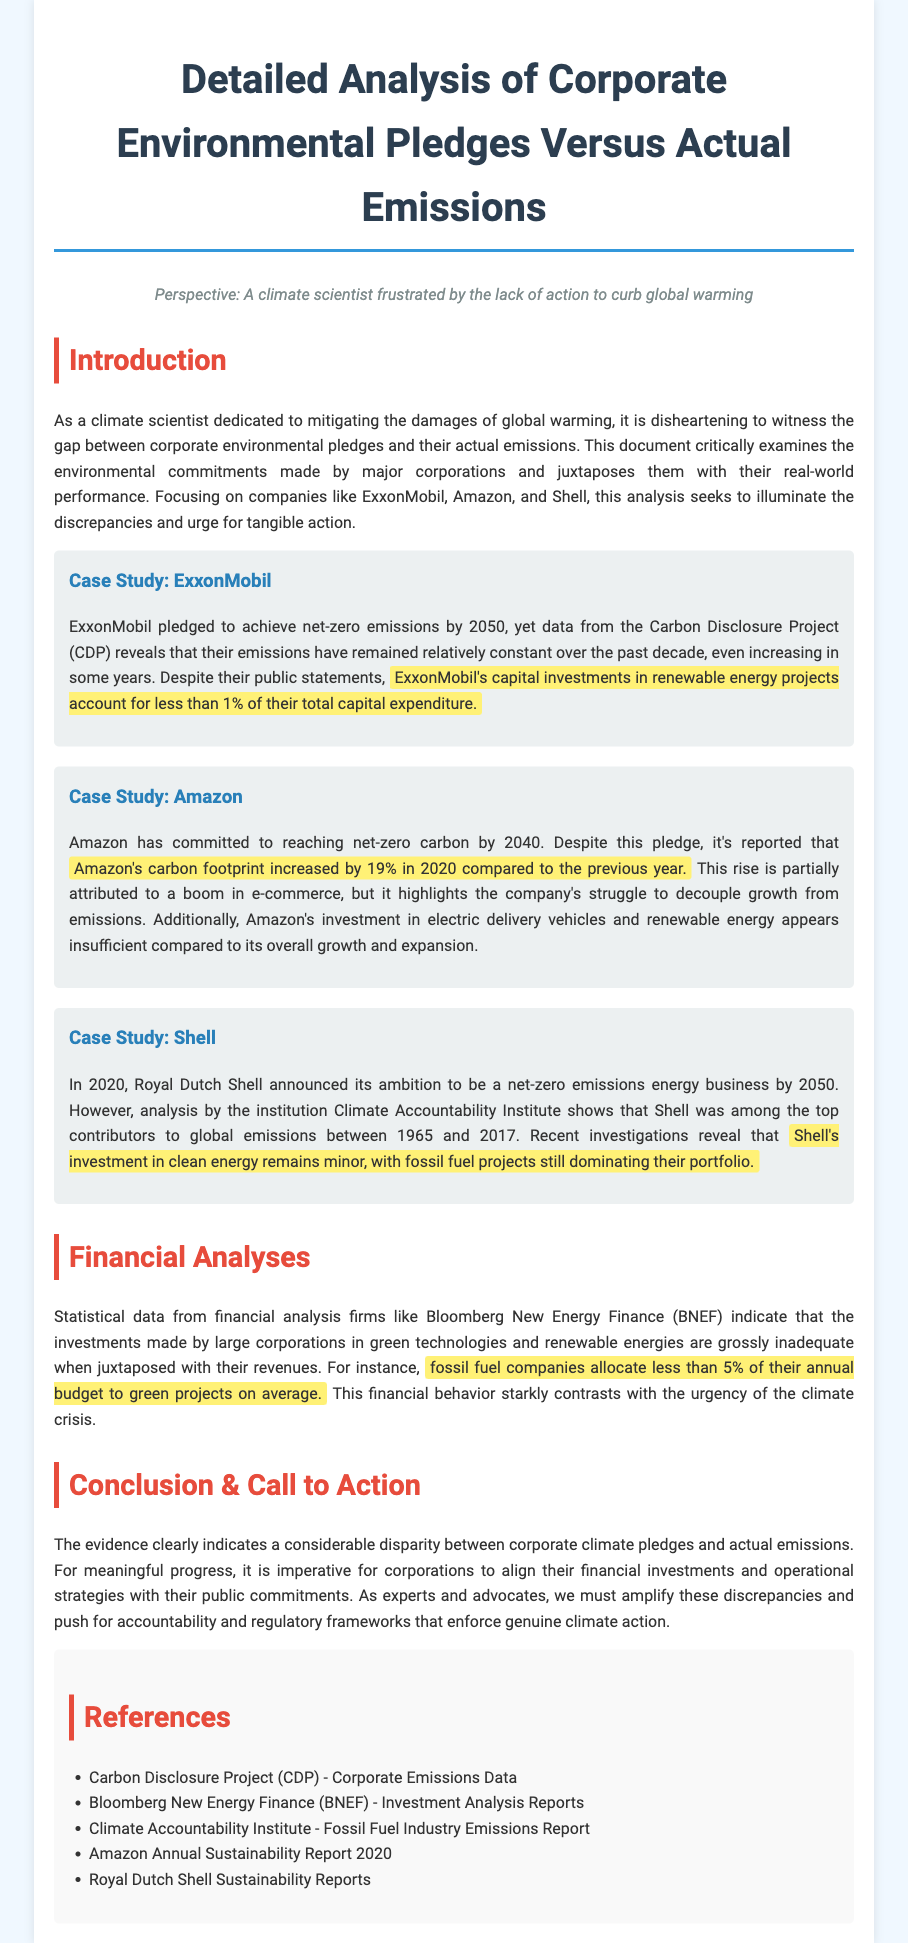What is the net-zero emissions target year for ExxonMobil? ExxonMobil pledged to achieve net-zero emissions by 2050, as stated in the case study.
Answer: 2050 What percentage of their total capital expenditure does ExxonMobil allocate to renewable energy? It is mentioned that ExxonMobil's capital investments in renewable energy account for less than 1% of their total capital expenditure.
Answer: less than 1% By what percentage did Amazon's carbon footprint increase in 2020? The document mentions that Amazon's carbon footprint increased by 19% in 2020 compared to the previous year.
Answer: 19% What is Shell’s ambition regarding net-zero emissions? According to the case study, Shell announced its ambition to be a net-zero emissions energy business by 2050.
Answer: net-zero emissions energy business by 2050 What percentage of their annual budget do fossil fuel companies allocate to green projects, on average? The financial analysis indicates that fossil fuel companies allocate less than 5% of their annual budget to green projects on average.
Answer: less than 5% What is the main issue highlighted in the conclusion regarding corporate pledges? The conclusion states that there is a considerable disparity between corporate climate pledges and actual emissions, emphasizing the need for accountability.
Answer: considerable disparity Which corporation is noted for having a carbon footprint increase due to e-commerce growth? The case study regarding Amazon identifies their carbon footprint increase as partially attributed to a boom in e-commerce.
Answer: Amazon What does the document highlight as necessary for meaningful progress in climate action? It emphasizes the need for corporations to align their financial investments and operational strategies with their public commitments.
Answer: align investments and strategies 